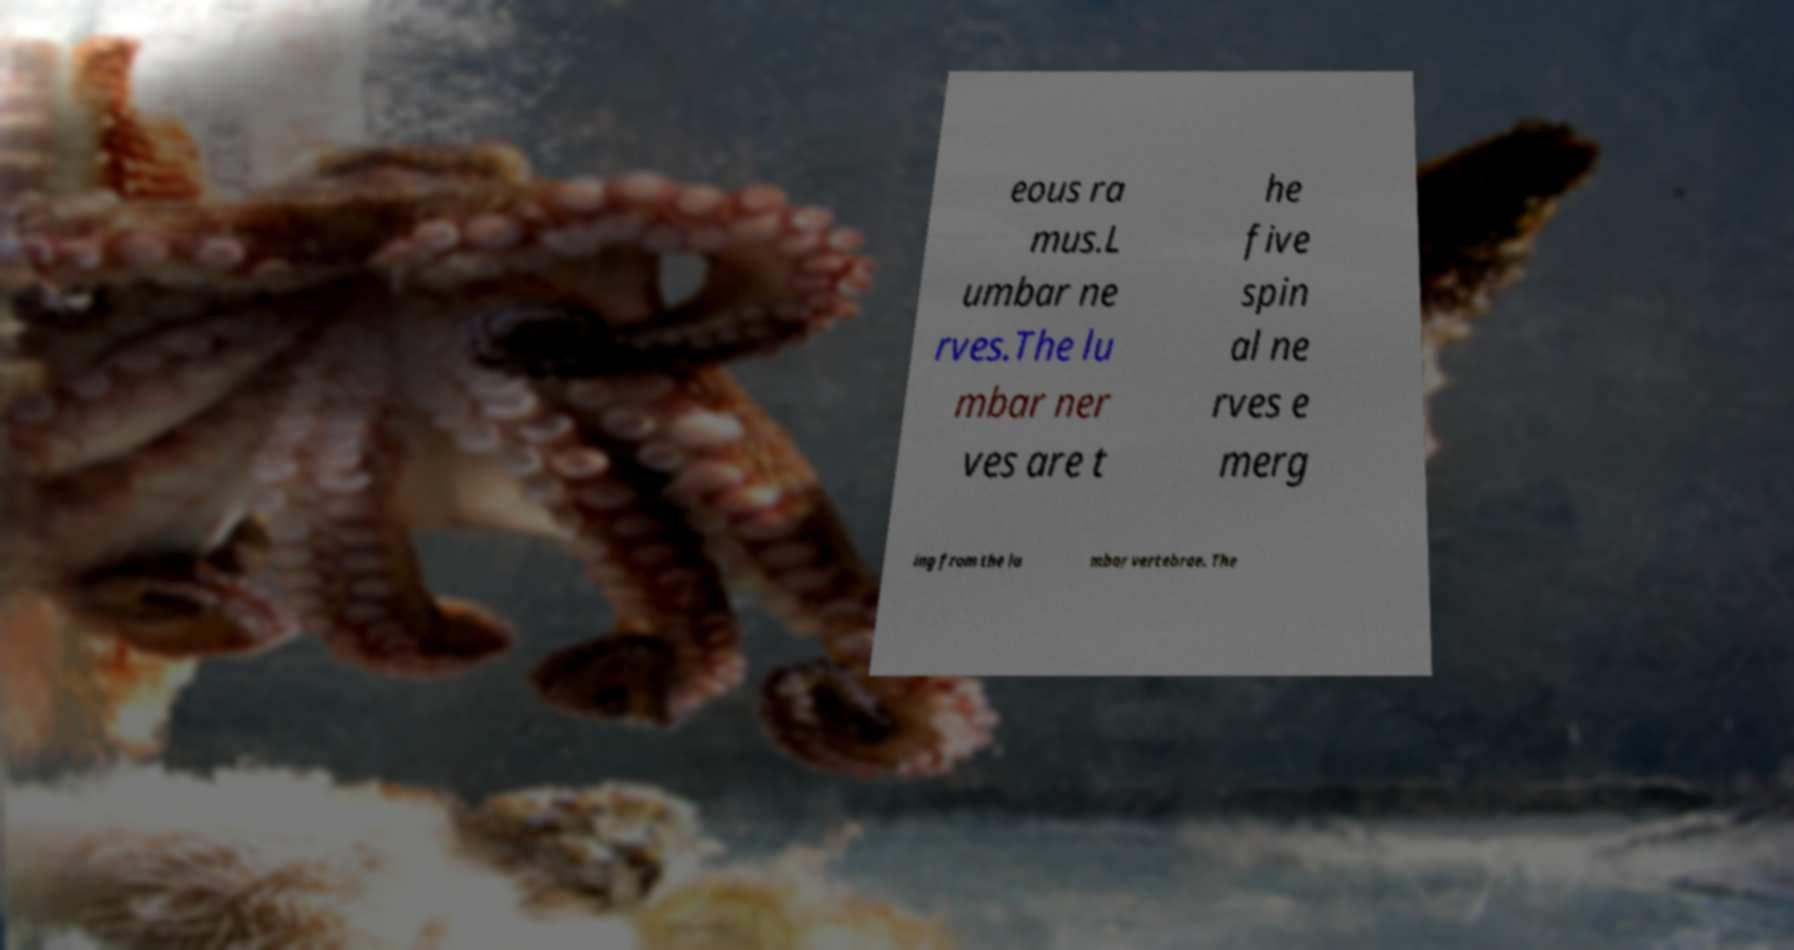Could you assist in decoding the text presented in this image and type it out clearly? eous ra mus.L umbar ne rves.The lu mbar ner ves are t he five spin al ne rves e merg ing from the lu mbar vertebrae. The 